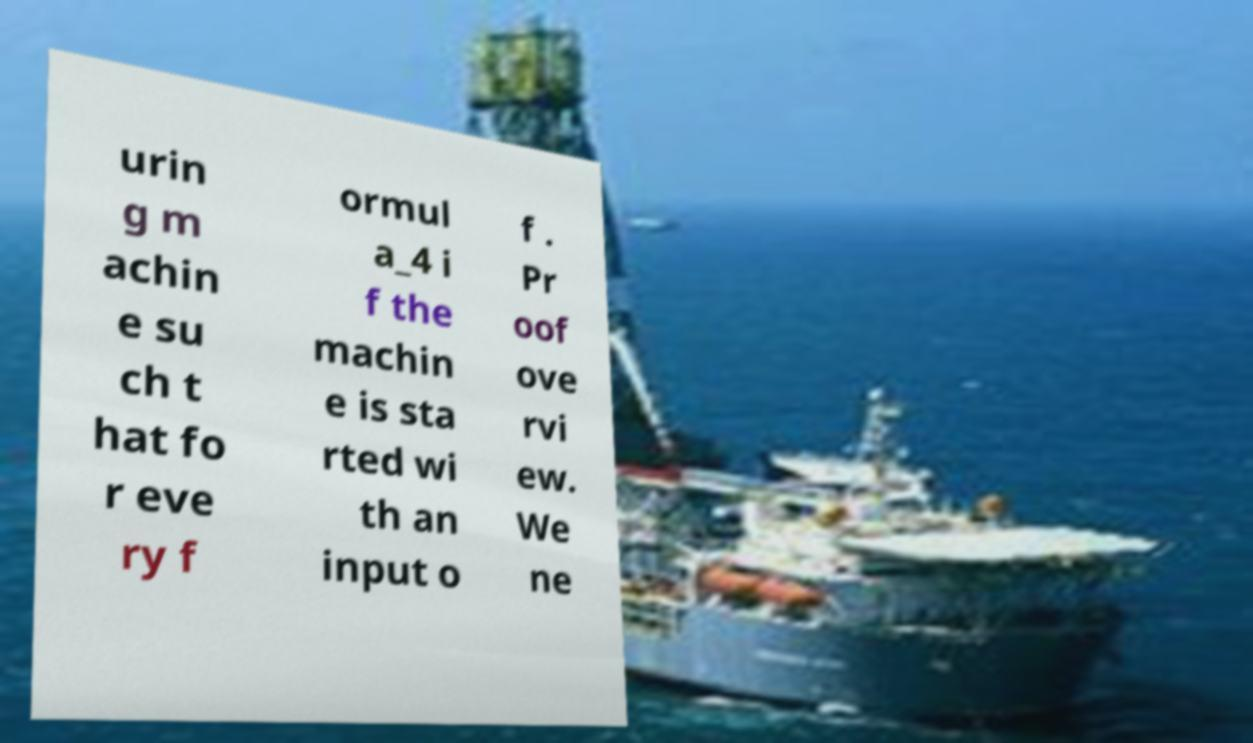For documentation purposes, I need the text within this image transcribed. Could you provide that? urin g m achin e su ch t hat fo r eve ry f ormul a_4 i f the machin e is sta rted wi th an input o f . Pr oof ove rvi ew. We ne 